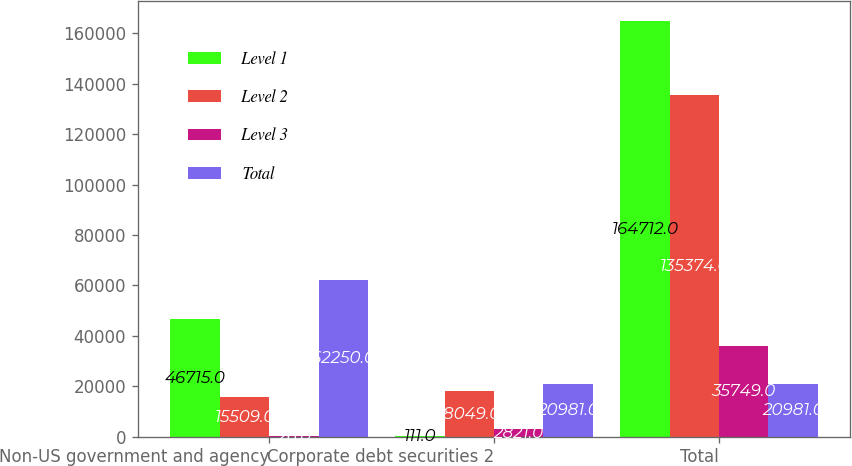Convert chart to OTSL. <chart><loc_0><loc_0><loc_500><loc_500><stacked_bar_chart><ecel><fcel>Non-US government and agency<fcel>Corporate debt securities 2<fcel>Total<nl><fcel>Level 1<fcel>46715<fcel>111<fcel>164712<nl><fcel>Level 2<fcel>15509<fcel>18049<fcel>135374<nl><fcel>Level 3<fcel>26<fcel>2821<fcel>35749<nl><fcel>Total<fcel>62250<fcel>20981<fcel>20981<nl></chart> 